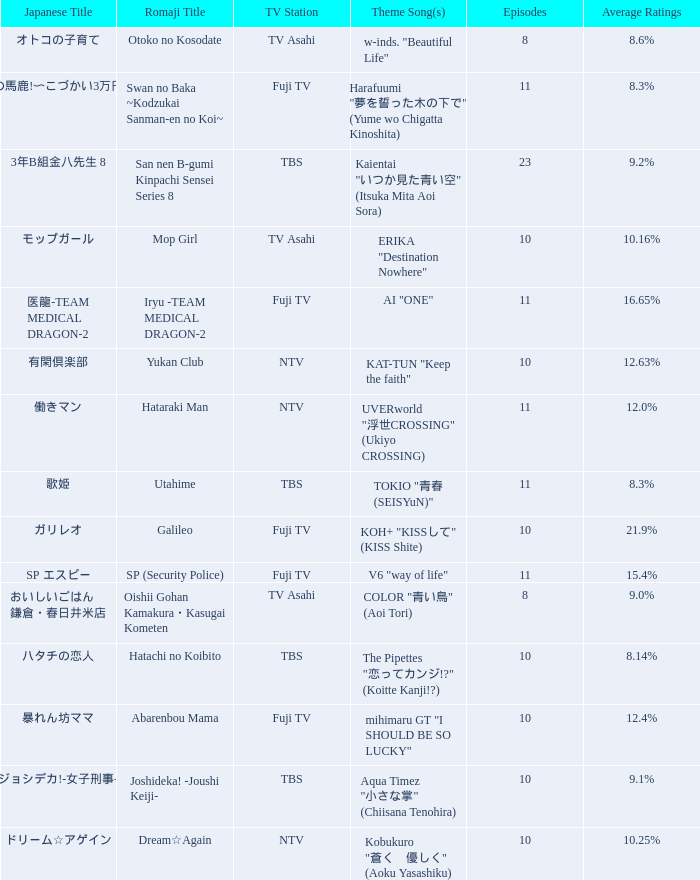What Episode has a Theme Song of koh+ "kissして" (kiss shite)? 10.0. 